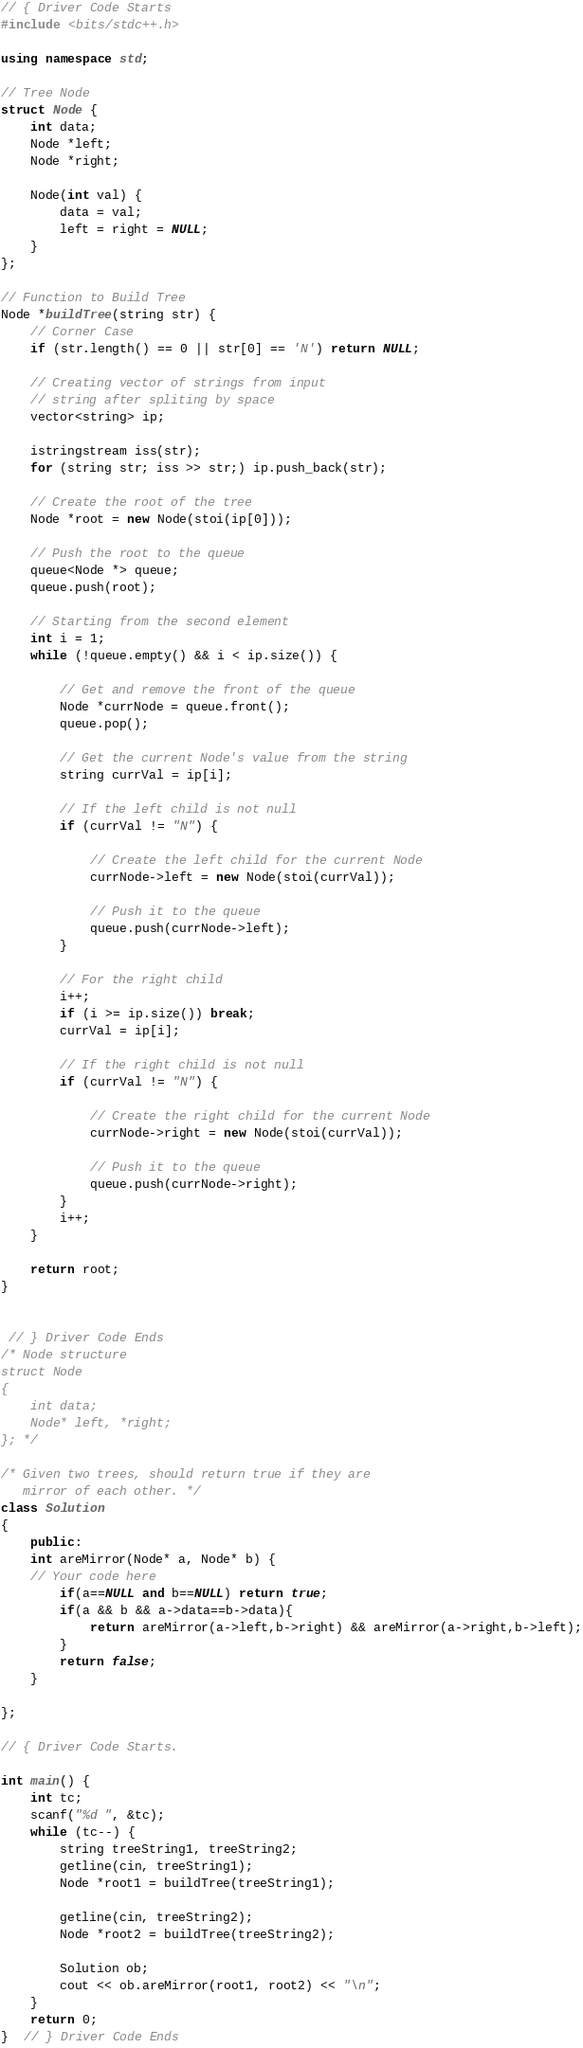<code> <loc_0><loc_0><loc_500><loc_500><_C++_>// { Driver Code Starts
#include <bits/stdc++.h>

using namespace std;

// Tree Node
struct Node {
    int data;
    Node *left;
    Node *right;

    Node(int val) {
        data = val;
        left = right = NULL;
    }
};

// Function to Build Tree
Node *buildTree(string str) {
    // Corner Case
    if (str.length() == 0 || str[0] == 'N') return NULL;

    // Creating vector of strings from input
    // string after spliting by space
    vector<string> ip;

    istringstream iss(str);
    for (string str; iss >> str;) ip.push_back(str);

    // Create the root of the tree
    Node *root = new Node(stoi(ip[0]));

    // Push the root to the queue
    queue<Node *> queue;
    queue.push(root);

    // Starting from the second element
    int i = 1;
    while (!queue.empty() && i < ip.size()) {

        // Get and remove the front of the queue
        Node *currNode = queue.front();
        queue.pop();

        // Get the current Node's value from the string
        string currVal = ip[i];

        // If the left child is not null
        if (currVal != "N") {

            // Create the left child for the current Node
            currNode->left = new Node(stoi(currVal));

            // Push it to the queue
            queue.push(currNode->left);
        }

        // For the right child
        i++;
        if (i >= ip.size()) break;
        currVal = ip[i];

        // If the right child is not null
        if (currVal != "N") {

            // Create the right child for the current Node
            currNode->right = new Node(stoi(currVal));

            // Push it to the queue
            queue.push(currNode->right);
        }
        i++;
    }

    return root;
}


 // } Driver Code Ends
/* Node structure
struct Node
{
    int data;
    Node* left, *right;
}; */

/* Given two trees, should return true if they are
   mirror of each other. */
class Solution
{
    public:
    int areMirror(Node* a, Node* b) {
    // Your code here
        if(a==NULL and b==NULL) return true;
        if(a && b && a->data==b->data){
            return areMirror(a->left,b->right) && areMirror(a->right,b->left);
        }
        return false;
    }

};

// { Driver Code Starts.

int main() {
    int tc;
    scanf("%d ", &tc);
    while (tc--) {
        string treeString1, treeString2;
        getline(cin, treeString1);
        Node *root1 = buildTree(treeString1);

        getline(cin, treeString2);
        Node *root2 = buildTree(treeString2);

        Solution ob;
        cout << ob.areMirror(root1, root2) << "\n";
    }
    return 0;
}  // } Driver Code Ends</code> 